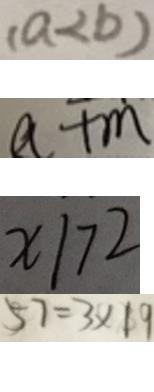<formula> <loc_0><loc_0><loc_500><loc_500>( a < b ) 
 a + m 
 x \vert 7 2 
 5 7 = 3 \times 1 9</formula> 